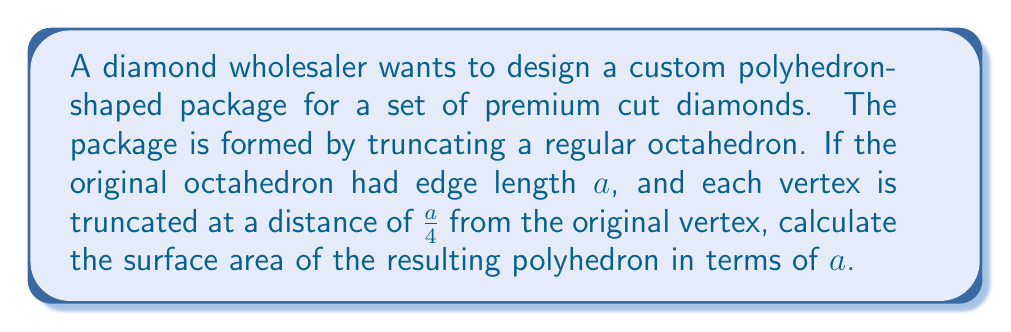Can you solve this math problem? Let's approach this step-by-step:

1) First, we need to understand what shape we're dealing with. By truncating a regular octahedron, we create a polyhedron with 14 faces: 6 regular octagons (from the original triangular faces) and 8 regular triangles (from the truncated vertices).

2) Let's calculate the area of one octagonal face:
   - The original edge length of the octahedron is $a$.
   - After truncation, each edge of the octagon is reduced by $\frac{a}{4}$ on each end.
   - So, the edge length of the octagon is $a - 2(\frac{a}{4}) = \frac{a}{2}$.
   - The area of a regular octagon with side length $s$ is given by $2s^2(1+\sqrt{2})$.
   - Substituting $s = \frac{a}{2}$, we get: $2(\frac{a}{2})^2(1+\sqrt{2}) = \frac{a^2}{2}(1+\sqrt{2})$.

3) Now, let's calculate the area of one triangular face:
   - The edge length of each triangular face is $\frac{a}{\sqrt{2}}$.
   - The area of an equilateral triangle with side length $s$ is $\frac{\sqrt{3}}{4}s^2$.
   - Substituting $s = \frac{a}{\sqrt{2}}$, we get: $\frac{\sqrt{3}}{4}(\frac{a}{\sqrt{2}})^2 = \frac{\sqrt{3}}{8}a^2$.

4) To get the total surface area, we multiply the octagon area by 6 and the triangle area by 8, then sum:
   Total Surface Area = $6[\frac{a^2}{2}(1+\sqrt{2})] + 8[\frac{\sqrt{3}}{8}a^2]$
                      = $3a^2(1+\sqrt{2}) + a^2\sqrt{3}$
                      = $a^2(3+3\sqrt{2}+\sqrt{3})$

Therefore, the surface area of the truncated octahedron is $a^2(3+3\sqrt{2}+\sqrt{3})$.
Answer: $a^2(3+3\sqrt{2}+\sqrt{3})$ 